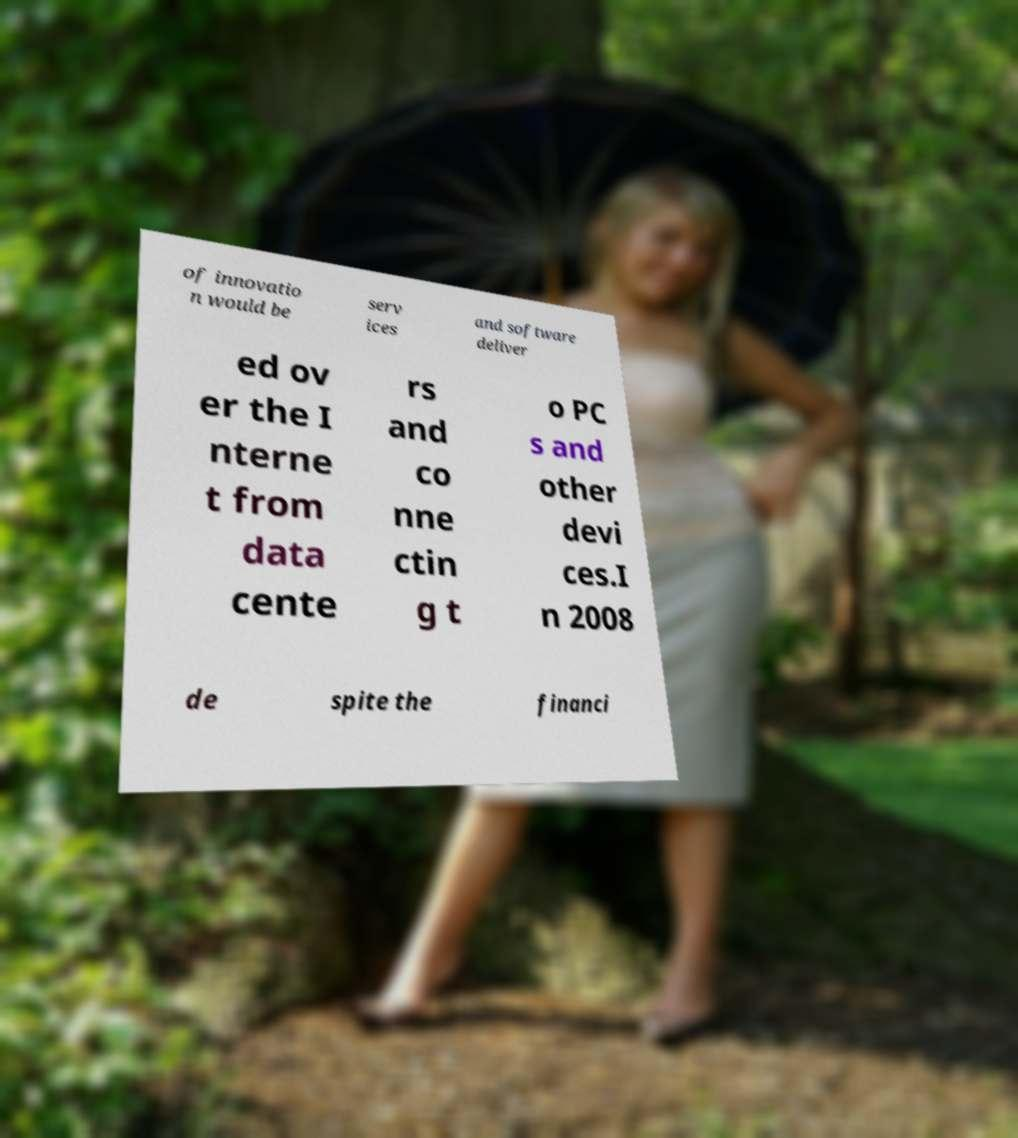For documentation purposes, I need the text within this image transcribed. Could you provide that? of innovatio n would be serv ices and software deliver ed ov er the I nterne t from data cente rs and co nne ctin g t o PC s and other devi ces.I n 2008 de spite the financi 